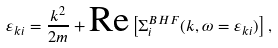<formula> <loc_0><loc_0><loc_500><loc_500>\varepsilon _ { k i } = \frac { k ^ { 2 } } { 2 m } + \text {Re} \left [ \Sigma _ { i } ^ { B H F } ( k , \omega = \varepsilon _ { k i } ) \right ] ,</formula> 